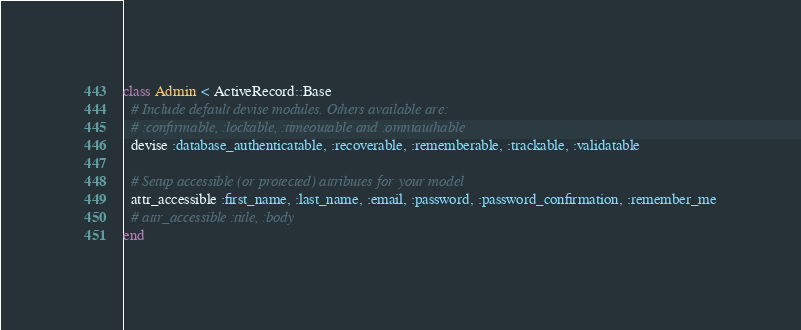<code> <loc_0><loc_0><loc_500><loc_500><_Ruby_>class Admin < ActiveRecord::Base
  # Include default devise modules. Others available are:
  # :confirmable, :lockable, :timeoutable and :omniauthable
  devise :database_authenticatable, :recoverable, :rememberable, :trackable, :validatable

  # Setup accessible (or protected) attributes for your model
  attr_accessible :first_name, :last_name, :email, :password, :password_confirmation, :remember_me
  # attr_accessible :title, :body
end
</code> 